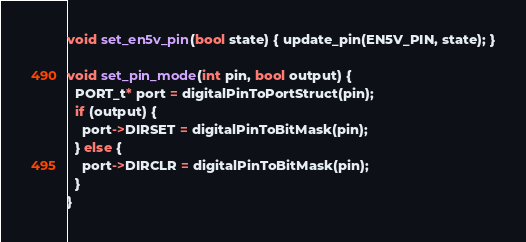<code> <loc_0><loc_0><loc_500><loc_500><_C++_>void set_en5v_pin(bool state) { update_pin(EN5V_PIN, state); }

void set_pin_mode(int pin, bool output) {
  PORT_t* port = digitalPinToPortStruct(pin);
  if (output) {
    port->DIRSET = digitalPinToBitMask(pin);
  } else {
    port->DIRCLR = digitalPinToBitMask(pin);
  }
}
</code> 